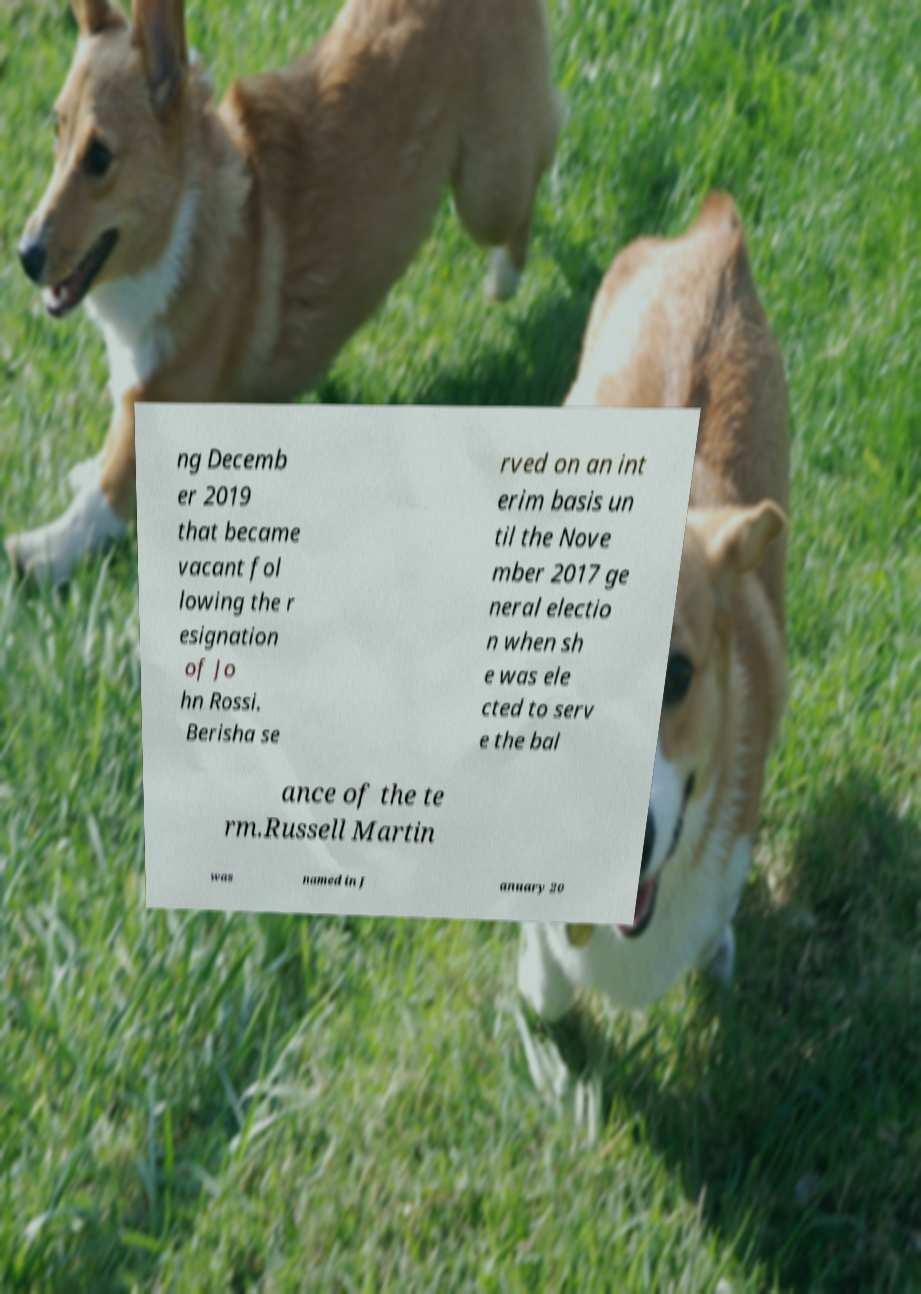Please identify and transcribe the text found in this image. ng Decemb er 2019 that became vacant fol lowing the r esignation of Jo hn Rossi. Berisha se rved on an int erim basis un til the Nove mber 2017 ge neral electio n when sh e was ele cted to serv e the bal ance of the te rm.Russell Martin was named in J anuary 20 